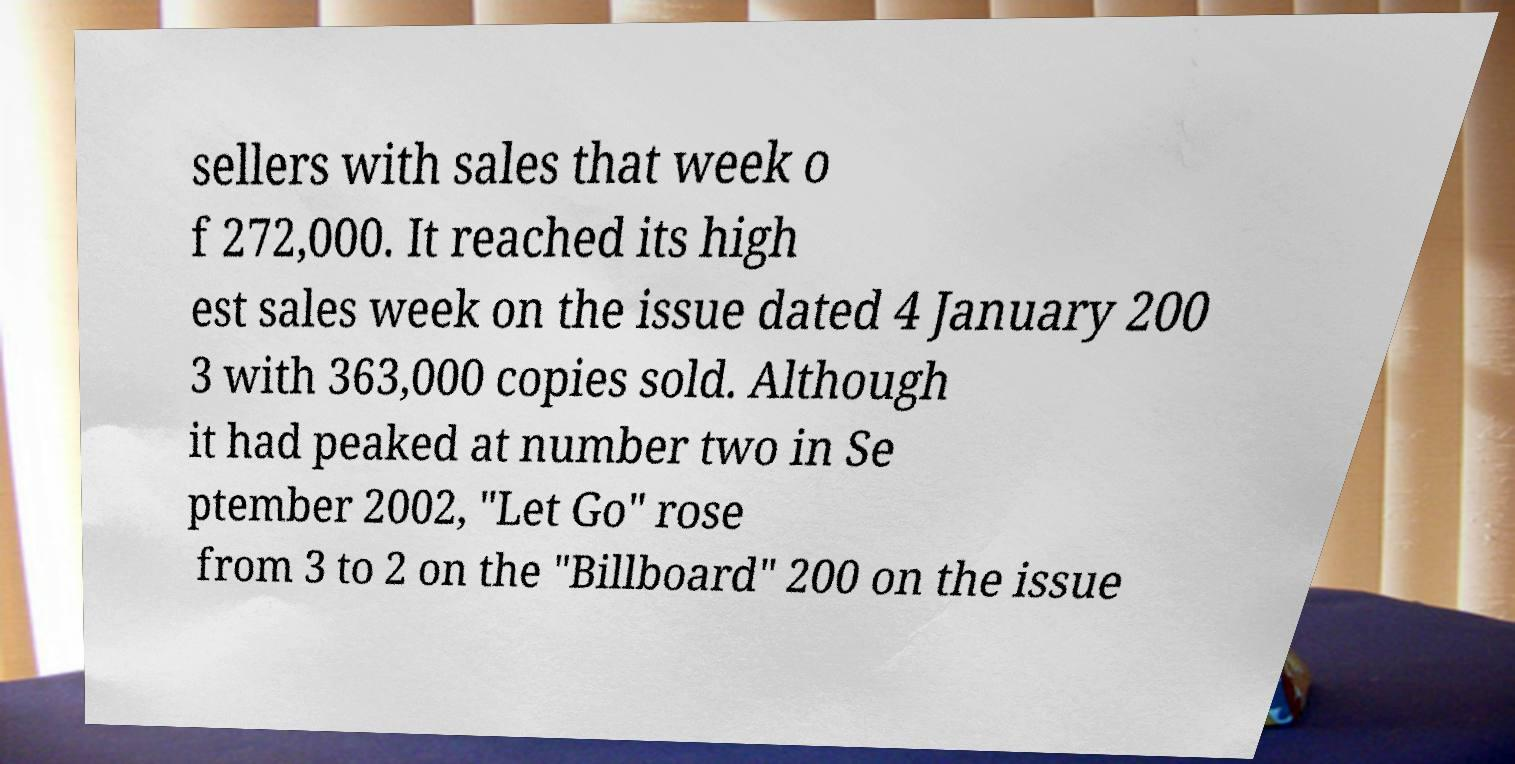What messages or text are displayed in this image? I need them in a readable, typed format. sellers with sales that week o f 272,000. It reached its high est sales week on the issue dated 4 January 200 3 with 363,000 copies sold. Although it had peaked at number two in Se ptember 2002, "Let Go" rose from 3 to 2 on the "Billboard" 200 on the issue 